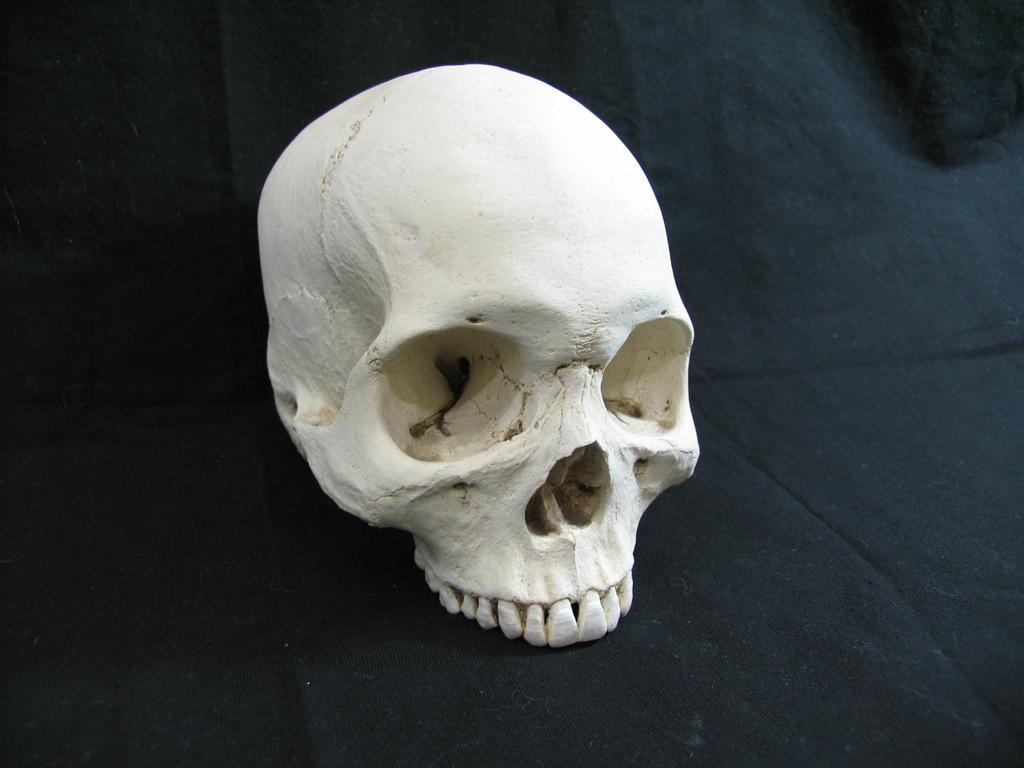What is the main subject of the image? The main subject of the image is a white color human skeleton head. What is the human skeleton head placed on? The human skeleton head is placed on a black color cloth. What type of chain is wrapped around the rose in the image? There is no chain or rose present in the image; it only features a white color human skeleton head placed on a black color cloth. 